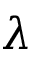<formula> <loc_0><loc_0><loc_500><loc_500>\lambda</formula> 